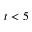<formula> <loc_0><loc_0><loc_500><loc_500>t < 5</formula> 